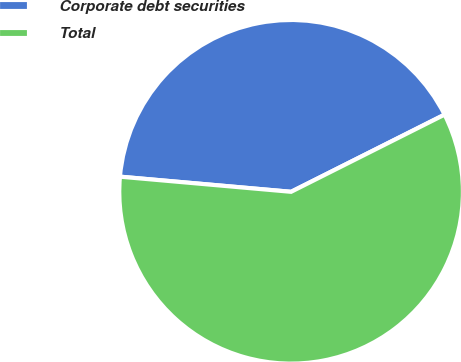Convert chart. <chart><loc_0><loc_0><loc_500><loc_500><pie_chart><fcel>Corporate debt securities<fcel>Total<nl><fcel>41.18%<fcel>58.82%<nl></chart> 